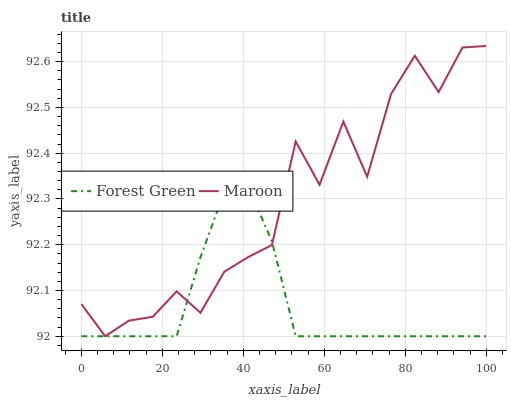Does Forest Green have the minimum area under the curve?
Answer yes or no. Yes. Does Maroon have the maximum area under the curve?
Answer yes or no. Yes. Does Maroon have the minimum area under the curve?
Answer yes or no. No. Is Forest Green the smoothest?
Answer yes or no. Yes. Is Maroon the roughest?
Answer yes or no. Yes. Is Maroon the smoothest?
Answer yes or no. No. Does Maroon have the highest value?
Answer yes or no. Yes. Does Forest Green intersect Maroon?
Answer yes or no. Yes. Is Forest Green less than Maroon?
Answer yes or no. No. Is Forest Green greater than Maroon?
Answer yes or no. No. 